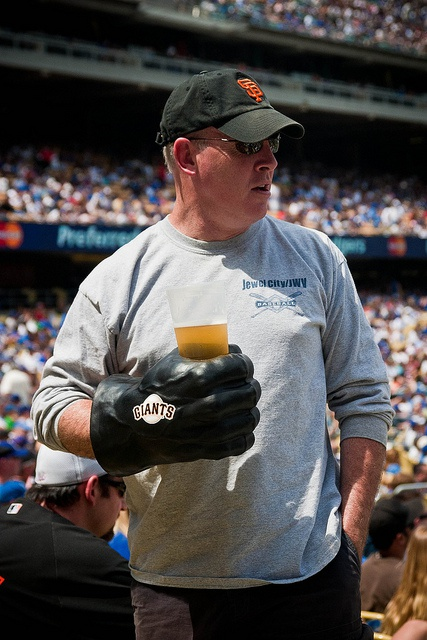Describe the objects in this image and their specific colors. I can see people in black, gray, lightgray, and darkgray tones, people in black, maroon, lightgray, and darkgray tones, cup in black, lightgray, orange, and olive tones, people in black, maroon, and brown tones, and people in black, maroon, olive, and salmon tones in this image. 